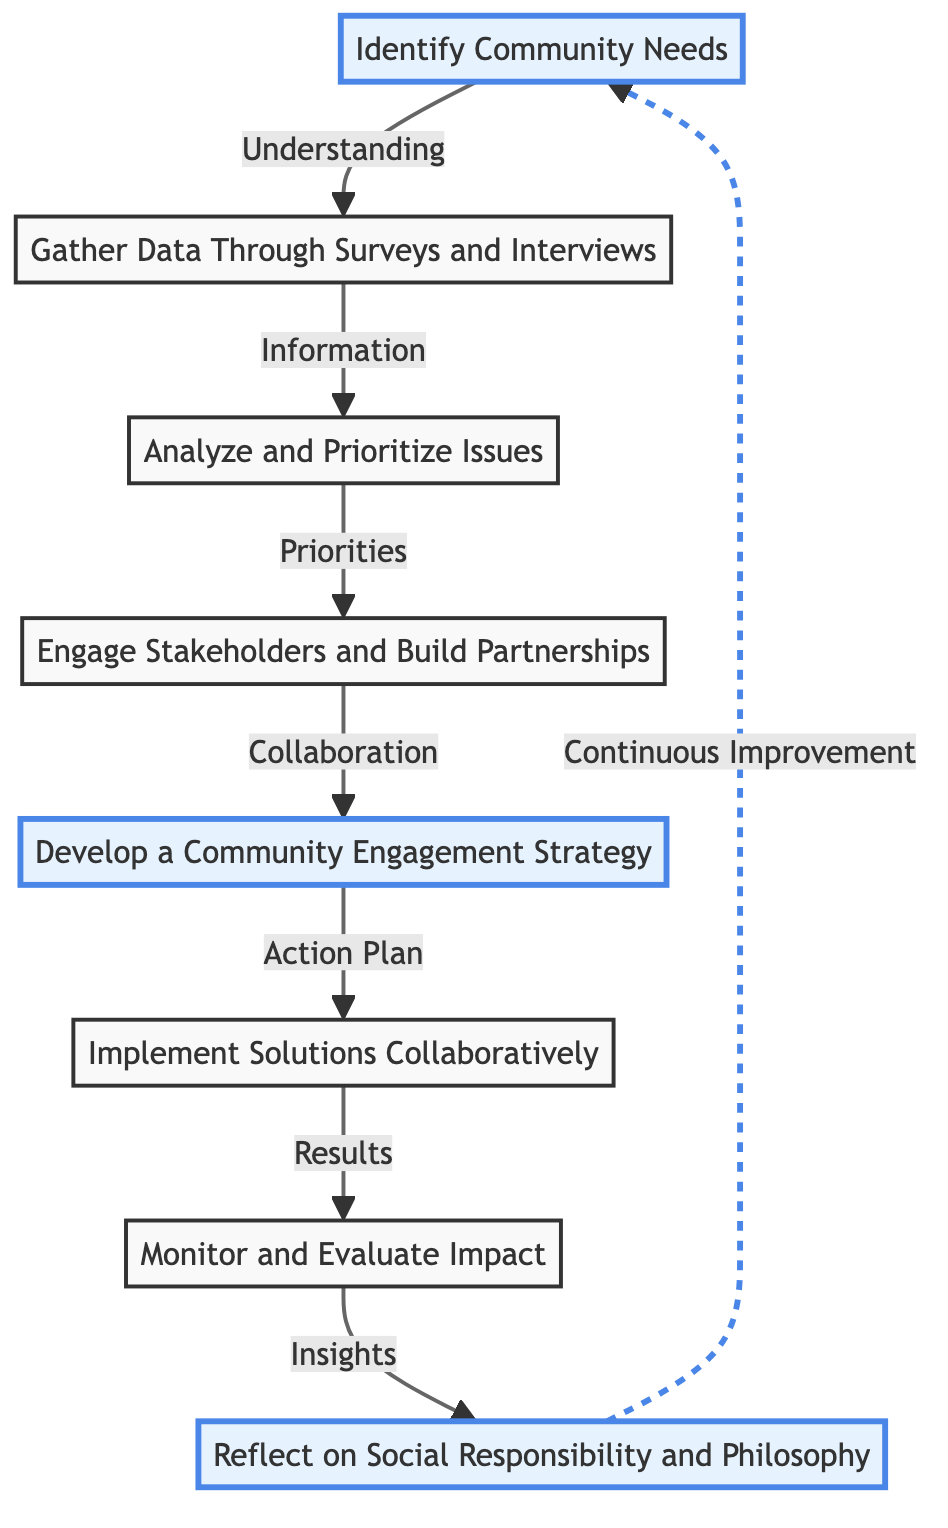What is the first step in the community engagement process? The first step in the flowchart is marked as "Identify Community Needs," which is the starting point of the process.
Answer: Identify Community Needs How many nodes are in the diagram? The diagram contains a total of 8 nodes, representing different stages in the community engagement plan.
Answer: 8 What does the connection from "Analyze and Prioritize Issues" lead to? The connection from "Analyze and Prioritize Issues" leads to "Engage Stakeholders and Build Partnerships," indicating the next step in the process after analyzing the issues.
Answer: Engage Stakeholders and Build Partnerships Which step emphasizes the development of a strategy? The step labeled "Develop a Community Engagement Strategy" specifically focuses on the formulation of a strategy following the engagement of stakeholders.
Answer: Develop a Community Engagement Strategy What is the outcome of the "Implement Solutions Collaboratively" node? The outcome of this node is "Monitor and Evaluate Impact," illustrating the subsequent action taken after implementing solutions.
Answer: Monitor and Evaluate Impact Which step represents a reflection on social responsibility? The step titled "Reflect on Social Responsibility and Philosophy" specifically highlights the importance of philosophical considerations and social responsibility in the community engagement process.
Answer: Reflect on Social Responsibility and Philosophy What is the type of relationship between "Monitor and Evaluate Impact" and "Identify Community Needs"? The relationship is indicated as a dashed line, symbolizing a feedback loop that allows for continuous improvement based on insights gained from monitoring impacts.
Answer: Continuous Improvement How does "Gather Data Through Surveys and Interviews" connect to the process? It connects to the "Analyze and Prioritize Issues" step, indicating that the data gathered will serve as the information necessary for analysis and prioritization.
Answer: Analyze and Prioritize Issues 